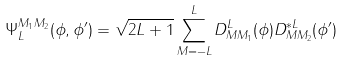<formula> <loc_0><loc_0><loc_500><loc_500>\Psi _ { L } ^ { M _ { 1 } M _ { 2 } } ( \phi , \phi ^ { \prime } ) = \sqrt { 2 L + 1 } \sum _ { M = - L } ^ { L } D ^ { L } _ { M M _ { 1 } } ( \phi ) D ^ { * L } _ { M M _ { 2 } } ( \phi ^ { \prime } )</formula> 